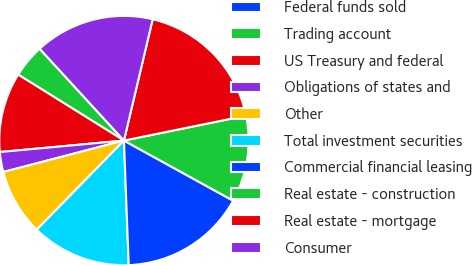Convert chart. <chart><loc_0><loc_0><loc_500><loc_500><pie_chart><fcel>Federal funds sold<fcel>Trading account<fcel>US Treasury and federal<fcel>Obligations of states and<fcel>Other<fcel>Total investment securities<fcel>Commercial financial leasing<fcel>Real estate - construction<fcel>Real estate - mortgage<fcel>Consumer<nl><fcel>0.0%<fcel>4.31%<fcel>10.34%<fcel>2.59%<fcel>8.62%<fcel>12.93%<fcel>16.38%<fcel>11.21%<fcel>18.1%<fcel>15.52%<nl></chart> 